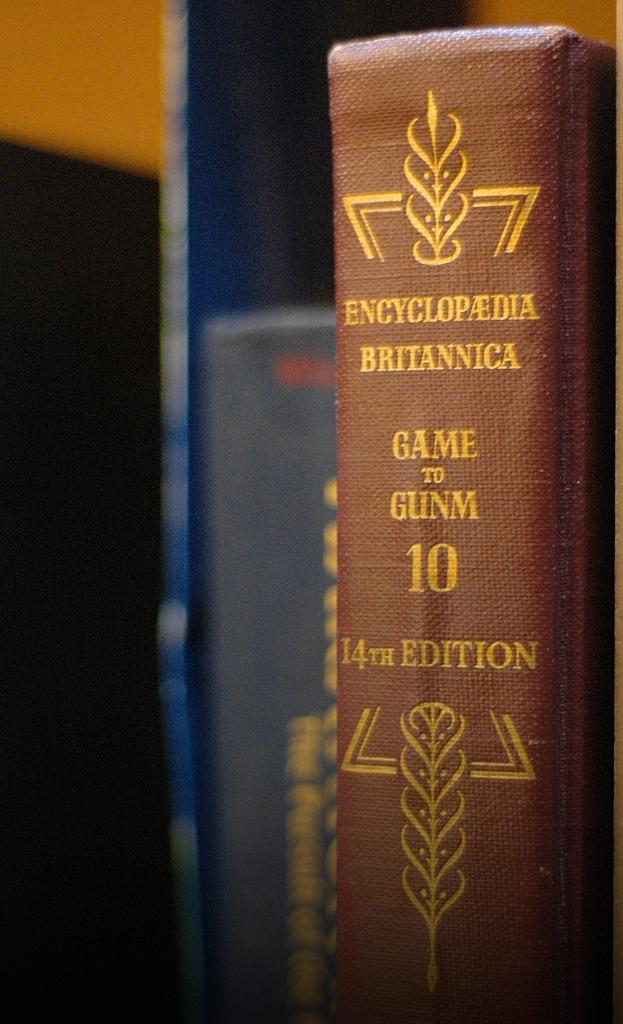<image>
Create a compact narrative representing the image presented. An encyclopedia Britannica sits with some other books. 